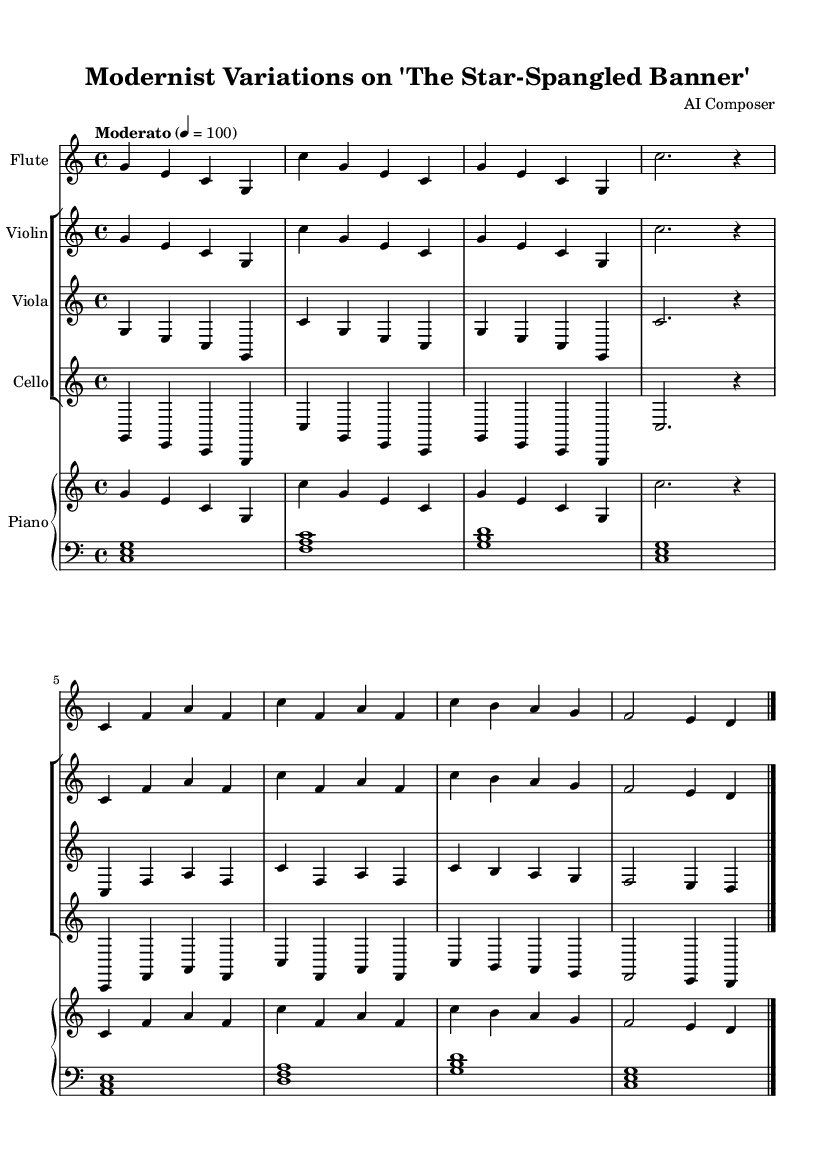What is the key signature of this music? The key signature is C major, which has no sharps or flats.
Answer: C major What is the time signature of this music? The time signature indicates that there are four beats in each measure, as denoted by the 4/4 notation.
Answer: 4/4 What is the tempo marking of the piece? The tempo marking is "Moderato," which suggests a moderate speed, specified by the metronome marking of 100 beats per minute.
Answer: Moderato How many different instruments are used in this arrangement? There are four instruments: Flute, Violin, Viola, and Cello, plus Piano, making a total of five.
Answer: Five What are the note values in the first measure for the flute part? The first measure has four quarter notes: g, e, c, and g, represented by the corresponding note durations in 4/4 time.
Answer: Four quarter notes Which melodic pattern is repeated in both the violin and viola parts? The melodic pattern that is repeated in both parts is the sequence g, e, c, g, indicating a common thematic material shared among the strings.
Answer: g, e, c, g What is the relationship of the left hand piano part to the right hand in the score? The left hand piano part primarily consists of chords supporting the melodic line in the right hand, creating harmonic depth beneath the melody.
Answer: Chords supporting melody 